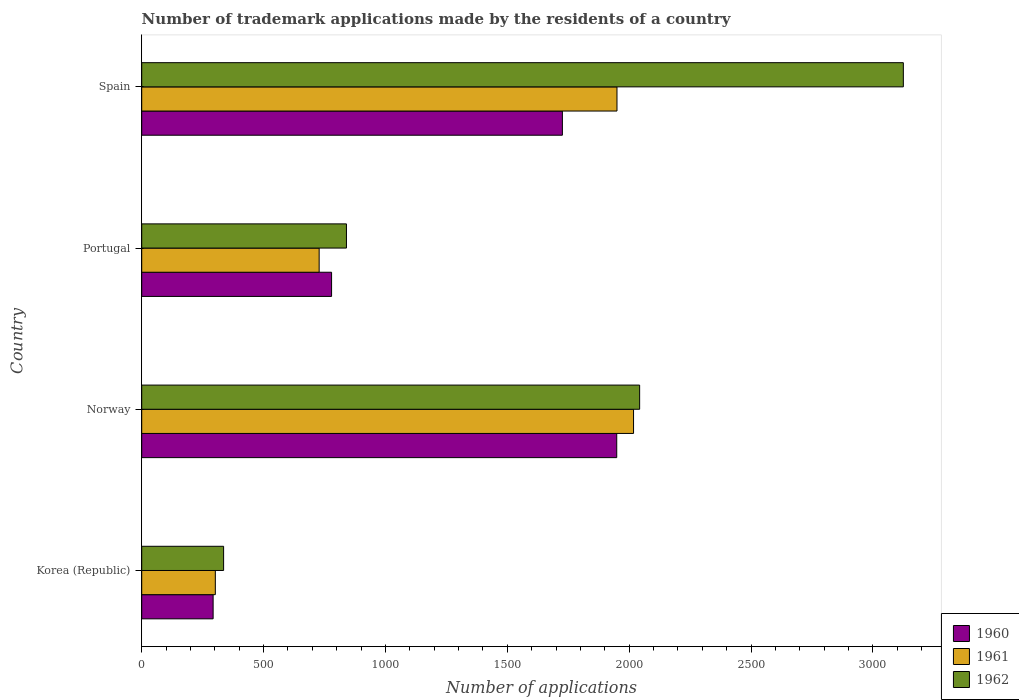How many different coloured bars are there?
Your response must be concise. 3. How many groups of bars are there?
Provide a succinct answer. 4. How many bars are there on the 4th tick from the bottom?
Your answer should be compact. 3. In how many cases, is the number of bars for a given country not equal to the number of legend labels?
Ensure brevity in your answer.  0. What is the number of trademark applications made by the residents in 1962 in Spain?
Make the answer very short. 3125. Across all countries, what is the maximum number of trademark applications made by the residents in 1960?
Offer a very short reply. 1949. Across all countries, what is the minimum number of trademark applications made by the residents in 1960?
Your answer should be very brief. 293. In which country was the number of trademark applications made by the residents in 1960 maximum?
Make the answer very short. Norway. What is the total number of trademark applications made by the residents in 1960 in the graph?
Offer a terse response. 4747. What is the difference between the number of trademark applications made by the residents in 1961 in Korea (Republic) and that in Norway?
Provide a succinct answer. -1716. What is the difference between the number of trademark applications made by the residents in 1961 in Norway and the number of trademark applications made by the residents in 1960 in Portugal?
Your response must be concise. 1239. What is the average number of trademark applications made by the residents in 1962 per country?
Provide a short and direct response. 1586. What is the difference between the number of trademark applications made by the residents in 1961 and number of trademark applications made by the residents in 1962 in Portugal?
Keep it short and to the point. -112. What is the ratio of the number of trademark applications made by the residents in 1961 in Norway to that in Portugal?
Provide a short and direct response. 2.77. Is the number of trademark applications made by the residents in 1960 in Norway less than that in Spain?
Keep it short and to the point. No. What is the difference between the highest and the second highest number of trademark applications made by the residents in 1962?
Give a very brief answer. 1082. What is the difference between the highest and the lowest number of trademark applications made by the residents in 1960?
Offer a very short reply. 1656. What does the 1st bar from the bottom in Korea (Republic) represents?
Make the answer very short. 1960. What is the difference between two consecutive major ticks on the X-axis?
Give a very brief answer. 500. Are the values on the major ticks of X-axis written in scientific E-notation?
Provide a succinct answer. No. Does the graph contain any zero values?
Keep it short and to the point. No. Does the graph contain grids?
Give a very brief answer. No. What is the title of the graph?
Provide a short and direct response. Number of trademark applications made by the residents of a country. What is the label or title of the X-axis?
Make the answer very short. Number of applications. What is the Number of applications of 1960 in Korea (Republic)?
Ensure brevity in your answer.  293. What is the Number of applications in 1961 in Korea (Republic)?
Your answer should be compact. 302. What is the Number of applications of 1962 in Korea (Republic)?
Ensure brevity in your answer.  336. What is the Number of applications of 1960 in Norway?
Offer a terse response. 1949. What is the Number of applications in 1961 in Norway?
Offer a terse response. 2018. What is the Number of applications in 1962 in Norway?
Make the answer very short. 2043. What is the Number of applications of 1960 in Portugal?
Provide a short and direct response. 779. What is the Number of applications of 1961 in Portugal?
Give a very brief answer. 728. What is the Number of applications of 1962 in Portugal?
Your response must be concise. 840. What is the Number of applications in 1960 in Spain?
Keep it short and to the point. 1726. What is the Number of applications of 1961 in Spain?
Make the answer very short. 1950. What is the Number of applications of 1962 in Spain?
Provide a short and direct response. 3125. Across all countries, what is the maximum Number of applications in 1960?
Give a very brief answer. 1949. Across all countries, what is the maximum Number of applications in 1961?
Offer a very short reply. 2018. Across all countries, what is the maximum Number of applications in 1962?
Keep it short and to the point. 3125. Across all countries, what is the minimum Number of applications of 1960?
Provide a short and direct response. 293. Across all countries, what is the minimum Number of applications of 1961?
Your response must be concise. 302. Across all countries, what is the minimum Number of applications in 1962?
Provide a short and direct response. 336. What is the total Number of applications of 1960 in the graph?
Your response must be concise. 4747. What is the total Number of applications of 1961 in the graph?
Give a very brief answer. 4998. What is the total Number of applications in 1962 in the graph?
Make the answer very short. 6344. What is the difference between the Number of applications of 1960 in Korea (Republic) and that in Norway?
Offer a very short reply. -1656. What is the difference between the Number of applications in 1961 in Korea (Republic) and that in Norway?
Provide a short and direct response. -1716. What is the difference between the Number of applications of 1962 in Korea (Republic) and that in Norway?
Make the answer very short. -1707. What is the difference between the Number of applications of 1960 in Korea (Republic) and that in Portugal?
Provide a succinct answer. -486. What is the difference between the Number of applications in 1961 in Korea (Republic) and that in Portugal?
Ensure brevity in your answer.  -426. What is the difference between the Number of applications in 1962 in Korea (Republic) and that in Portugal?
Give a very brief answer. -504. What is the difference between the Number of applications of 1960 in Korea (Republic) and that in Spain?
Your response must be concise. -1433. What is the difference between the Number of applications of 1961 in Korea (Republic) and that in Spain?
Offer a very short reply. -1648. What is the difference between the Number of applications of 1962 in Korea (Republic) and that in Spain?
Make the answer very short. -2789. What is the difference between the Number of applications of 1960 in Norway and that in Portugal?
Offer a very short reply. 1170. What is the difference between the Number of applications of 1961 in Norway and that in Portugal?
Ensure brevity in your answer.  1290. What is the difference between the Number of applications in 1962 in Norway and that in Portugal?
Give a very brief answer. 1203. What is the difference between the Number of applications in 1960 in Norway and that in Spain?
Keep it short and to the point. 223. What is the difference between the Number of applications in 1961 in Norway and that in Spain?
Provide a short and direct response. 68. What is the difference between the Number of applications in 1962 in Norway and that in Spain?
Offer a very short reply. -1082. What is the difference between the Number of applications in 1960 in Portugal and that in Spain?
Your response must be concise. -947. What is the difference between the Number of applications in 1961 in Portugal and that in Spain?
Provide a succinct answer. -1222. What is the difference between the Number of applications in 1962 in Portugal and that in Spain?
Your response must be concise. -2285. What is the difference between the Number of applications of 1960 in Korea (Republic) and the Number of applications of 1961 in Norway?
Your answer should be compact. -1725. What is the difference between the Number of applications of 1960 in Korea (Republic) and the Number of applications of 1962 in Norway?
Make the answer very short. -1750. What is the difference between the Number of applications in 1961 in Korea (Republic) and the Number of applications in 1962 in Norway?
Offer a terse response. -1741. What is the difference between the Number of applications in 1960 in Korea (Republic) and the Number of applications in 1961 in Portugal?
Ensure brevity in your answer.  -435. What is the difference between the Number of applications in 1960 in Korea (Republic) and the Number of applications in 1962 in Portugal?
Give a very brief answer. -547. What is the difference between the Number of applications in 1961 in Korea (Republic) and the Number of applications in 1962 in Portugal?
Ensure brevity in your answer.  -538. What is the difference between the Number of applications in 1960 in Korea (Republic) and the Number of applications in 1961 in Spain?
Provide a succinct answer. -1657. What is the difference between the Number of applications in 1960 in Korea (Republic) and the Number of applications in 1962 in Spain?
Your answer should be compact. -2832. What is the difference between the Number of applications of 1961 in Korea (Republic) and the Number of applications of 1962 in Spain?
Keep it short and to the point. -2823. What is the difference between the Number of applications of 1960 in Norway and the Number of applications of 1961 in Portugal?
Keep it short and to the point. 1221. What is the difference between the Number of applications of 1960 in Norway and the Number of applications of 1962 in Portugal?
Make the answer very short. 1109. What is the difference between the Number of applications in 1961 in Norway and the Number of applications in 1962 in Portugal?
Offer a terse response. 1178. What is the difference between the Number of applications in 1960 in Norway and the Number of applications in 1961 in Spain?
Your answer should be very brief. -1. What is the difference between the Number of applications in 1960 in Norway and the Number of applications in 1962 in Spain?
Provide a short and direct response. -1176. What is the difference between the Number of applications of 1961 in Norway and the Number of applications of 1962 in Spain?
Offer a very short reply. -1107. What is the difference between the Number of applications of 1960 in Portugal and the Number of applications of 1961 in Spain?
Offer a very short reply. -1171. What is the difference between the Number of applications of 1960 in Portugal and the Number of applications of 1962 in Spain?
Offer a terse response. -2346. What is the difference between the Number of applications of 1961 in Portugal and the Number of applications of 1962 in Spain?
Ensure brevity in your answer.  -2397. What is the average Number of applications in 1960 per country?
Give a very brief answer. 1186.75. What is the average Number of applications of 1961 per country?
Your answer should be very brief. 1249.5. What is the average Number of applications in 1962 per country?
Provide a short and direct response. 1586. What is the difference between the Number of applications in 1960 and Number of applications in 1962 in Korea (Republic)?
Offer a terse response. -43. What is the difference between the Number of applications in 1961 and Number of applications in 1962 in Korea (Republic)?
Provide a succinct answer. -34. What is the difference between the Number of applications in 1960 and Number of applications in 1961 in Norway?
Your answer should be compact. -69. What is the difference between the Number of applications in 1960 and Number of applications in 1962 in Norway?
Ensure brevity in your answer.  -94. What is the difference between the Number of applications in 1960 and Number of applications in 1962 in Portugal?
Your answer should be compact. -61. What is the difference between the Number of applications of 1961 and Number of applications of 1962 in Portugal?
Offer a terse response. -112. What is the difference between the Number of applications in 1960 and Number of applications in 1961 in Spain?
Provide a short and direct response. -224. What is the difference between the Number of applications of 1960 and Number of applications of 1962 in Spain?
Give a very brief answer. -1399. What is the difference between the Number of applications of 1961 and Number of applications of 1962 in Spain?
Provide a short and direct response. -1175. What is the ratio of the Number of applications of 1960 in Korea (Republic) to that in Norway?
Provide a short and direct response. 0.15. What is the ratio of the Number of applications of 1961 in Korea (Republic) to that in Norway?
Your response must be concise. 0.15. What is the ratio of the Number of applications of 1962 in Korea (Republic) to that in Norway?
Provide a succinct answer. 0.16. What is the ratio of the Number of applications in 1960 in Korea (Republic) to that in Portugal?
Offer a terse response. 0.38. What is the ratio of the Number of applications in 1961 in Korea (Republic) to that in Portugal?
Your answer should be compact. 0.41. What is the ratio of the Number of applications of 1960 in Korea (Republic) to that in Spain?
Your answer should be compact. 0.17. What is the ratio of the Number of applications of 1961 in Korea (Republic) to that in Spain?
Provide a short and direct response. 0.15. What is the ratio of the Number of applications in 1962 in Korea (Republic) to that in Spain?
Your answer should be compact. 0.11. What is the ratio of the Number of applications of 1960 in Norway to that in Portugal?
Your answer should be very brief. 2.5. What is the ratio of the Number of applications of 1961 in Norway to that in Portugal?
Offer a very short reply. 2.77. What is the ratio of the Number of applications in 1962 in Norway to that in Portugal?
Provide a succinct answer. 2.43. What is the ratio of the Number of applications in 1960 in Norway to that in Spain?
Ensure brevity in your answer.  1.13. What is the ratio of the Number of applications of 1961 in Norway to that in Spain?
Give a very brief answer. 1.03. What is the ratio of the Number of applications of 1962 in Norway to that in Spain?
Make the answer very short. 0.65. What is the ratio of the Number of applications of 1960 in Portugal to that in Spain?
Offer a terse response. 0.45. What is the ratio of the Number of applications in 1961 in Portugal to that in Spain?
Give a very brief answer. 0.37. What is the ratio of the Number of applications of 1962 in Portugal to that in Spain?
Give a very brief answer. 0.27. What is the difference between the highest and the second highest Number of applications of 1960?
Provide a short and direct response. 223. What is the difference between the highest and the second highest Number of applications in 1961?
Keep it short and to the point. 68. What is the difference between the highest and the second highest Number of applications in 1962?
Ensure brevity in your answer.  1082. What is the difference between the highest and the lowest Number of applications of 1960?
Ensure brevity in your answer.  1656. What is the difference between the highest and the lowest Number of applications in 1961?
Give a very brief answer. 1716. What is the difference between the highest and the lowest Number of applications of 1962?
Provide a succinct answer. 2789. 